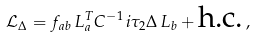Convert formula to latex. <formula><loc_0><loc_0><loc_500><loc_500>\mathcal { L } _ { \Delta } = f _ { a b } \, L ^ { T } _ { a } C ^ { - 1 } \, i \tau _ { 2 } \Delta \, L _ { b } + \text {h.c.} \, ,</formula> 